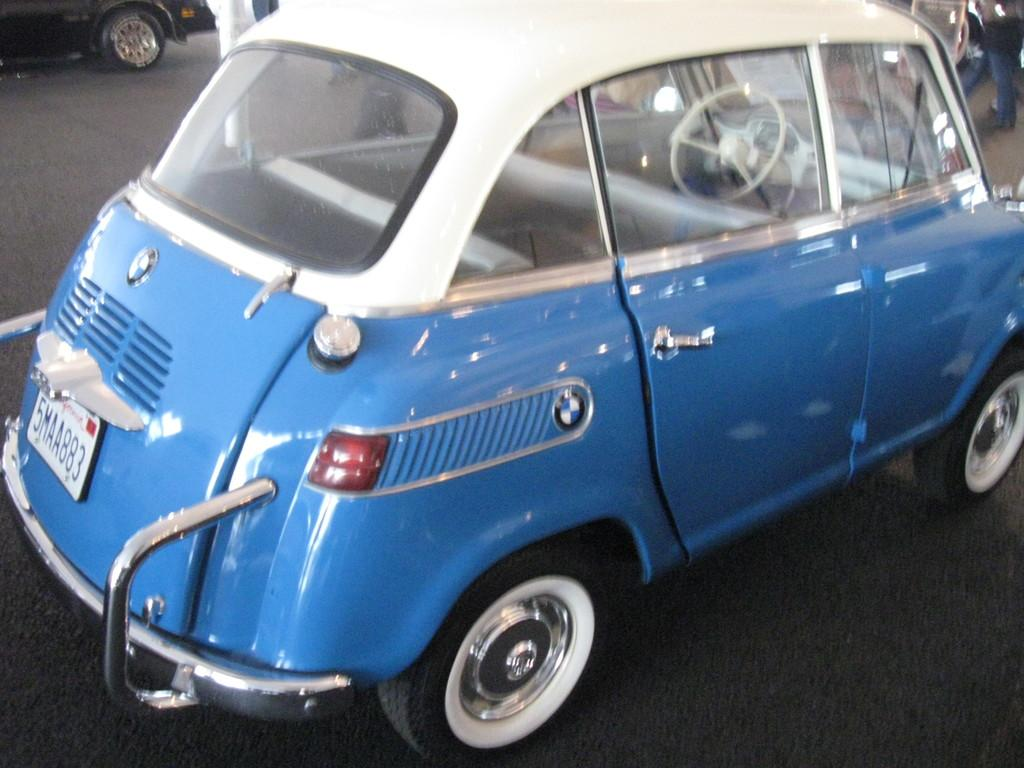What types of objects are present in the image? There are vehicles in the image. Can you describe any specific features of the people in the image? Person legs are visible in the image. What is the color scheme of one of the vehicles in the image? There is a blue and white vehicle in the image. What are the wheels of the blue and white vehicle like? The blue and white vehicle has wheels. Is there any identification visible on the blue and white vehicle? The blue and white vehicle has a number plate. What type of record is being played in the image? There is no record player or record visible in the image. 